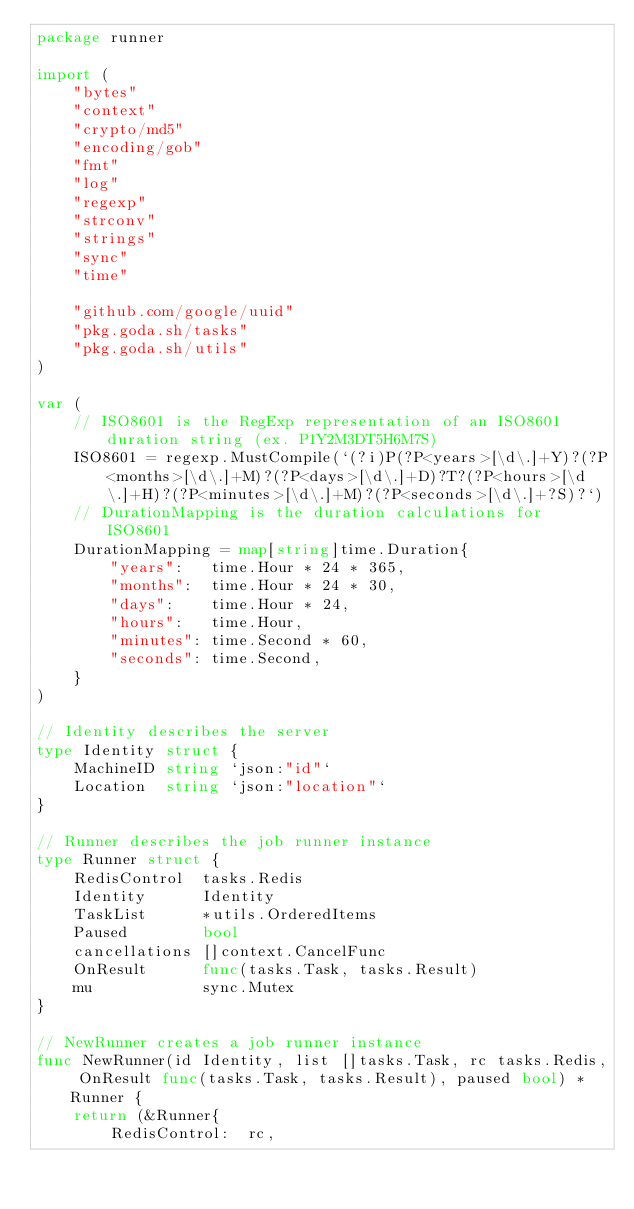<code> <loc_0><loc_0><loc_500><loc_500><_Go_>package runner

import (
	"bytes"
	"context"
	"crypto/md5"
	"encoding/gob"
	"fmt"
	"log"
	"regexp"
	"strconv"
	"strings"
	"sync"
	"time"

	"github.com/google/uuid"
	"pkg.goda.sh/tasks"
	"pkg.goda.sh/utils"
)

var (
	// ISO8601 is the RegExp representation of an ISO8601 duration string (ex. P1Y2M3DT5H6M7S)
	ISO8601 = regexp.MustCompile(`(?i)P(?P<years>[\d\.]+Y)?(?P<months>[\d\.]+M)?(?P<days>[\d\.]+D)?T?(?P<hours>[\d\.]+H)?(?P<minutes>[\d\.]+M)?(?P<seconds>[\d\.]+?S)?`)
	// DurationMapping is the duration calculations for ISO8601
	DurationMapping = map[string]time.Duration{
		"years":   time.Hour * 24 * 365,
		"months":  time.Hour * 24 * 30,
		"days":    time.Hour * 24,
		"hours":   time.Hour,
		"minutes": time.Second * 60,
		"seconds": time.Second,
	}
)

// Identity describes the server
type Identity struct {
	MachineID string `json:"id"`
	Location  string `json:"location"`
}

// Runner describes the job runner instance
type Runner struct {
	RedisControl  tasks.Redis
	Identity      Identity
	TaskList      *utils.OrderedItems
	Paused        bool
	cancellations []context.CancelFunc
	OnResult      func(tasks.Task, tasks.Result)
	mu            sync.Mutex
}

// NewRunner creates a job runner instance
func NewRunner(id Identity, list []tasks.Task, rc tasks.Redis, OnResult func(tasks.Task, tasks.Result), paused bool) *Runner {
	return (&Runner{
		RedisControl:  rc,</code> 